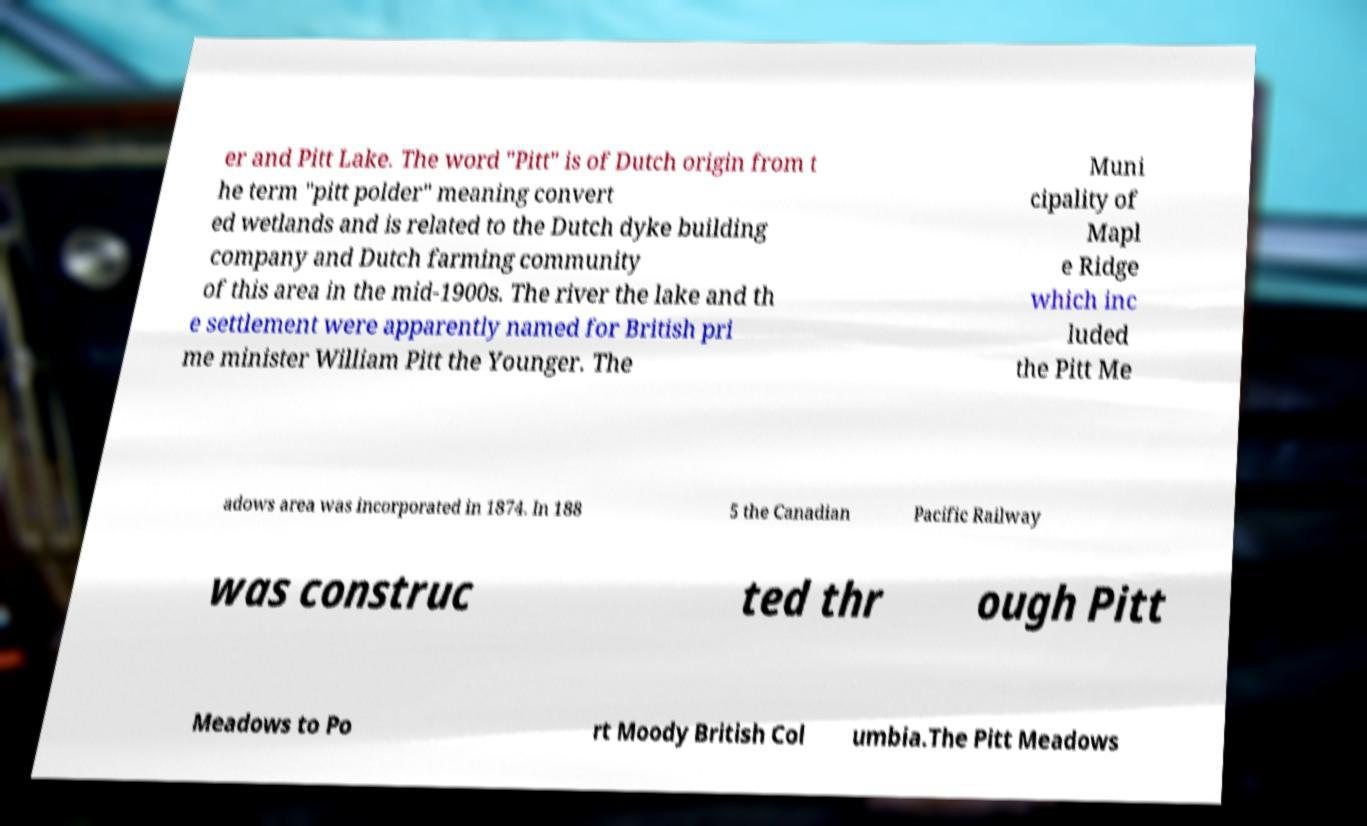Can you accurately transcribe the text from the provided image for me? er and Pitt Lake. The word "Pitt" is of Dutch origin from t he term "pitt polder" meaning convert ed wetlands and is related to the Dutch dyke building company and Dutch farming community of this area in the mid-1900s. The river the lake and th e settlement were apparently named for British pri me minister William Pitt the Younger. The Muni cipality of Mapl e Ridge which inc luded the Pitt Me adows area was incorporated in 1874. In 188 5 the Canadian Pacific Railway was construc ted thr ough Pitt Meadows to Po rt Moody British Col umbia.The Pitt Meadows 